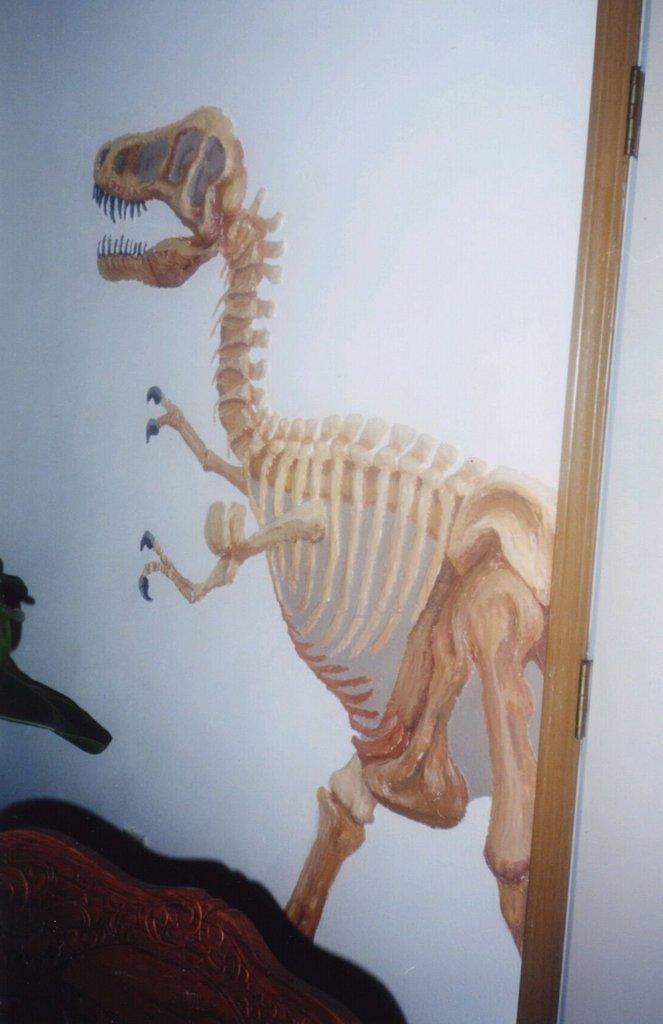What type of object is located at the bottom of the image? There is a wooden object at the bottom of the image. What can be seen on the wall in the center of the image? There is a dinosaur poster on the wall in the center of the image. What is present on the right side of the image? There is another wooden object on the right side of the image. What type of bottle is being used to feed the hen in the image? There is no bottle or hen present in the image. How does the wooden object on the right side of the image burn in the image? The wooden objects in the image do not burn; they are stationary and not on fire. 